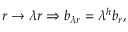Convert formula to latex. <formula><loc_0><loc_0><loc_500><loc_500>r \to \lambda r \Rightarrow b _ { \lambda r } = \lambda ^ { h } b _ { r } ,</formula> 